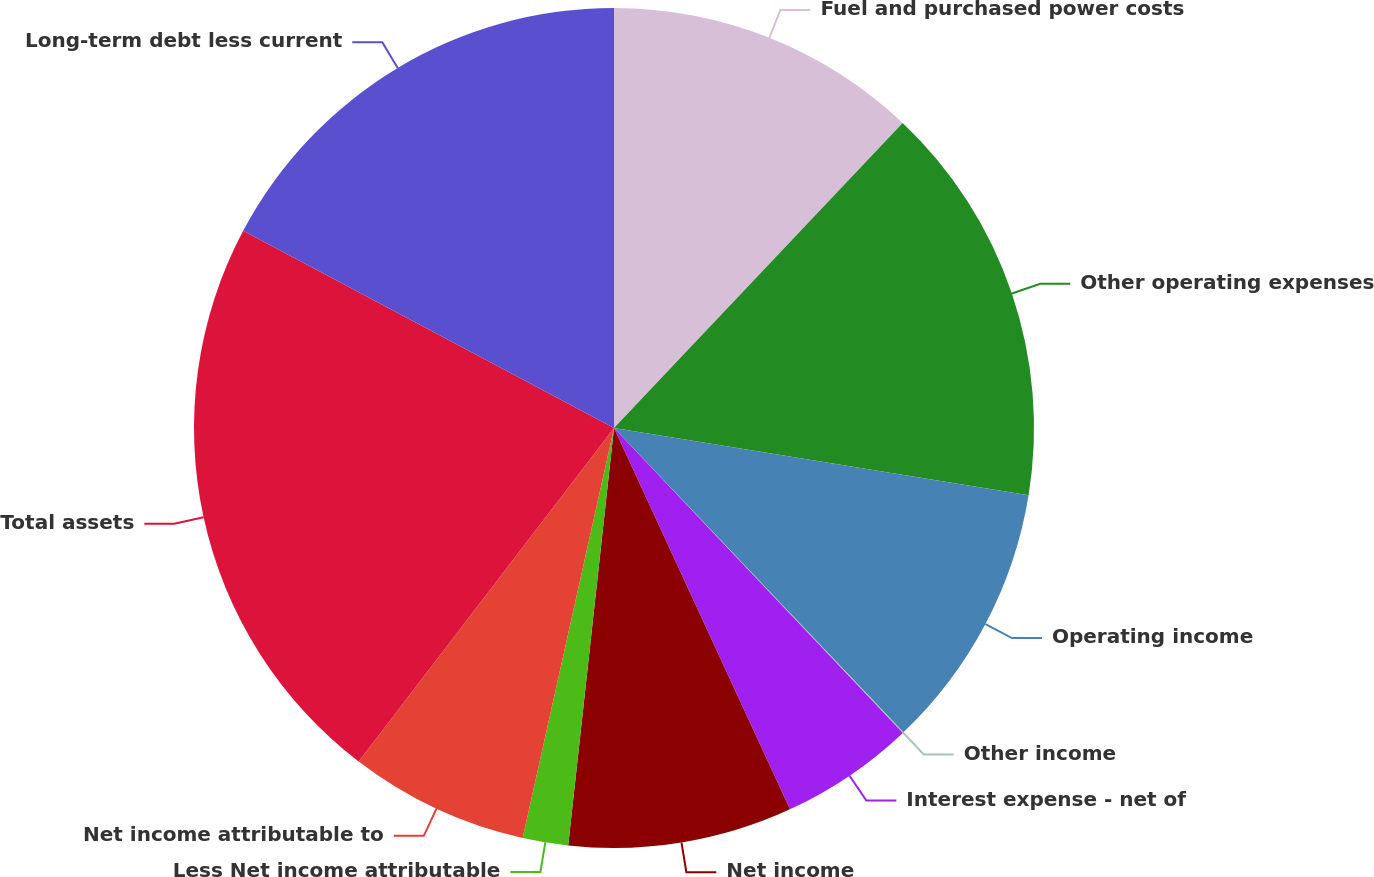<chart> <loc_0><loc_0><loc_500><loc_500><pie_chart><fcel>Fuel and purchased power costs<fcel>Other operating expenses<fcel>Operating income<fcel>Other income<fcel>Interest expense - net of<fcel>Net income<fcel>Less Net income attributable<fcel>Net income attributable to<fcel>Total assets<fcel>Long-term debt less current<nl><fcel>12.06%<fcel>15.5%<fcel>10.34%<fcel>0.03%<fcel>5.19%<fcel>8.62%<fcel>1.75%<fcel>6.91%<fcel>22.38%<fcel>17.22%<nl></chart> 